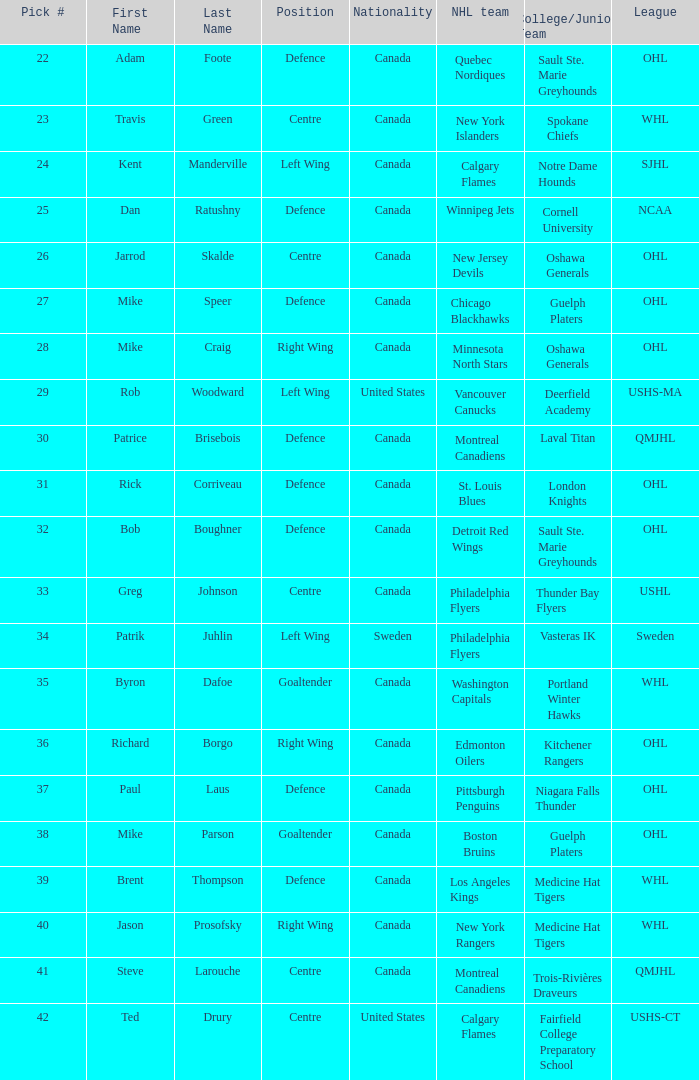How many draft picks is player byron dafoe? 1.0. 